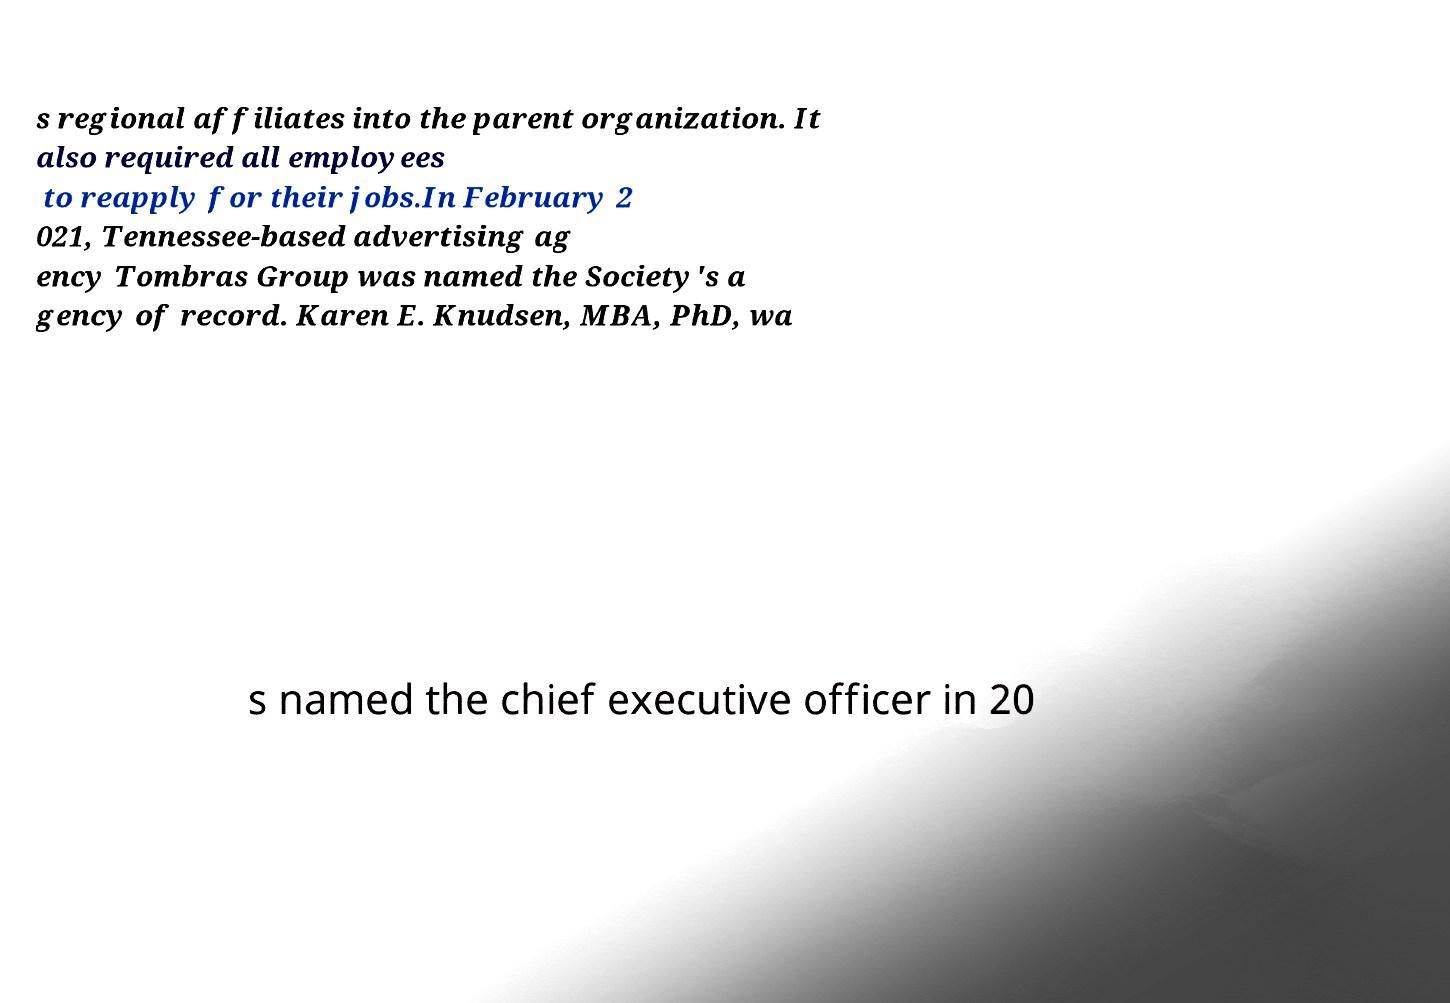What messages or text are displayed in this image? I need them in a readable, typed format. s regional affiliates into the parent organization. It also required all employees to reapply for their jobs.In February 2 021, Tennessee-based advertising ag ency Tombras Group was named the Society's a gency of record. Karen E. Knudsen, MBA, PhD, wa s named the chief executive officer in 20 